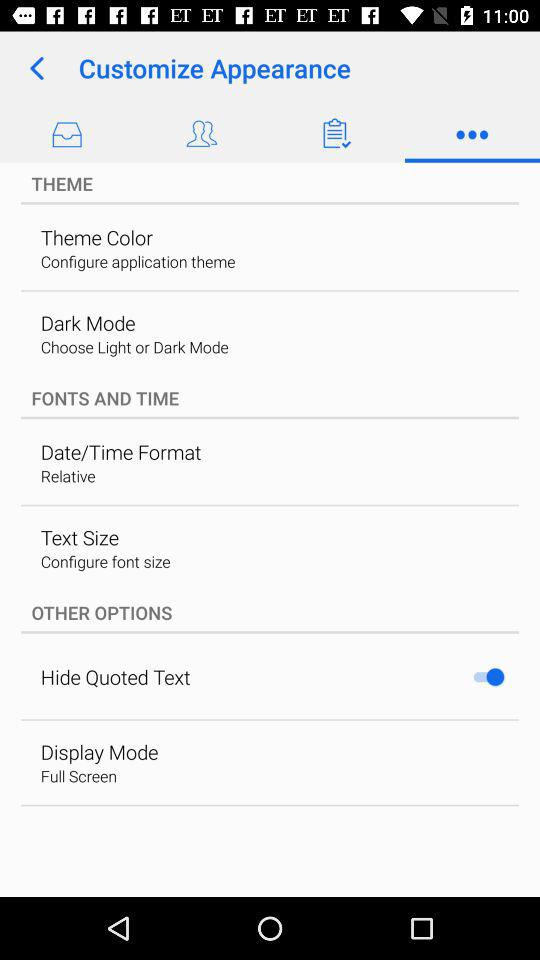Which text size is chosen? The chosen text size is "Configure font size". 